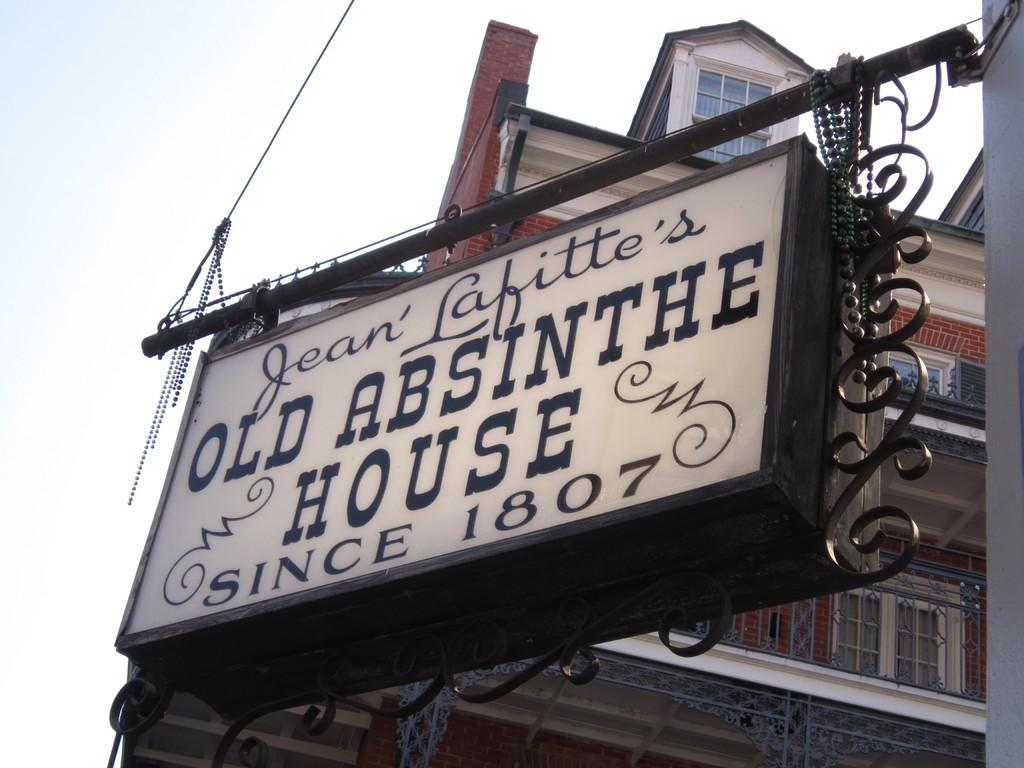What is on the board that is visible in the image? There is text on the board in the image. How is the board supported in the image? The board is fixed to poles. What can be seen in the distance in the image? There are buildings visible in the background of the image. What type of cabbage is being sold by the bear in the image? There is no bear or cabbage present in the image. How many tickets are available for the event in the image? There is no event or tickets mentioned or depicted in the image. 